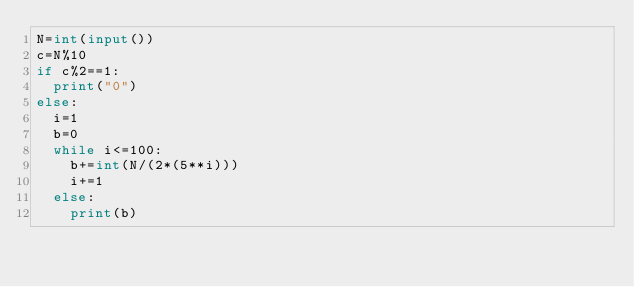Convert code to text. <code><loc_0><loc_0><loc_500><loc_500><_Python_>N=int(input())
c=N%10
if c%2==1:
  print("0")
else:
  i=1
  b=0
  while i<=100:
    b+=int(N/(2*(5**i)))
    i+=1
  else:
    print(b)</code> 